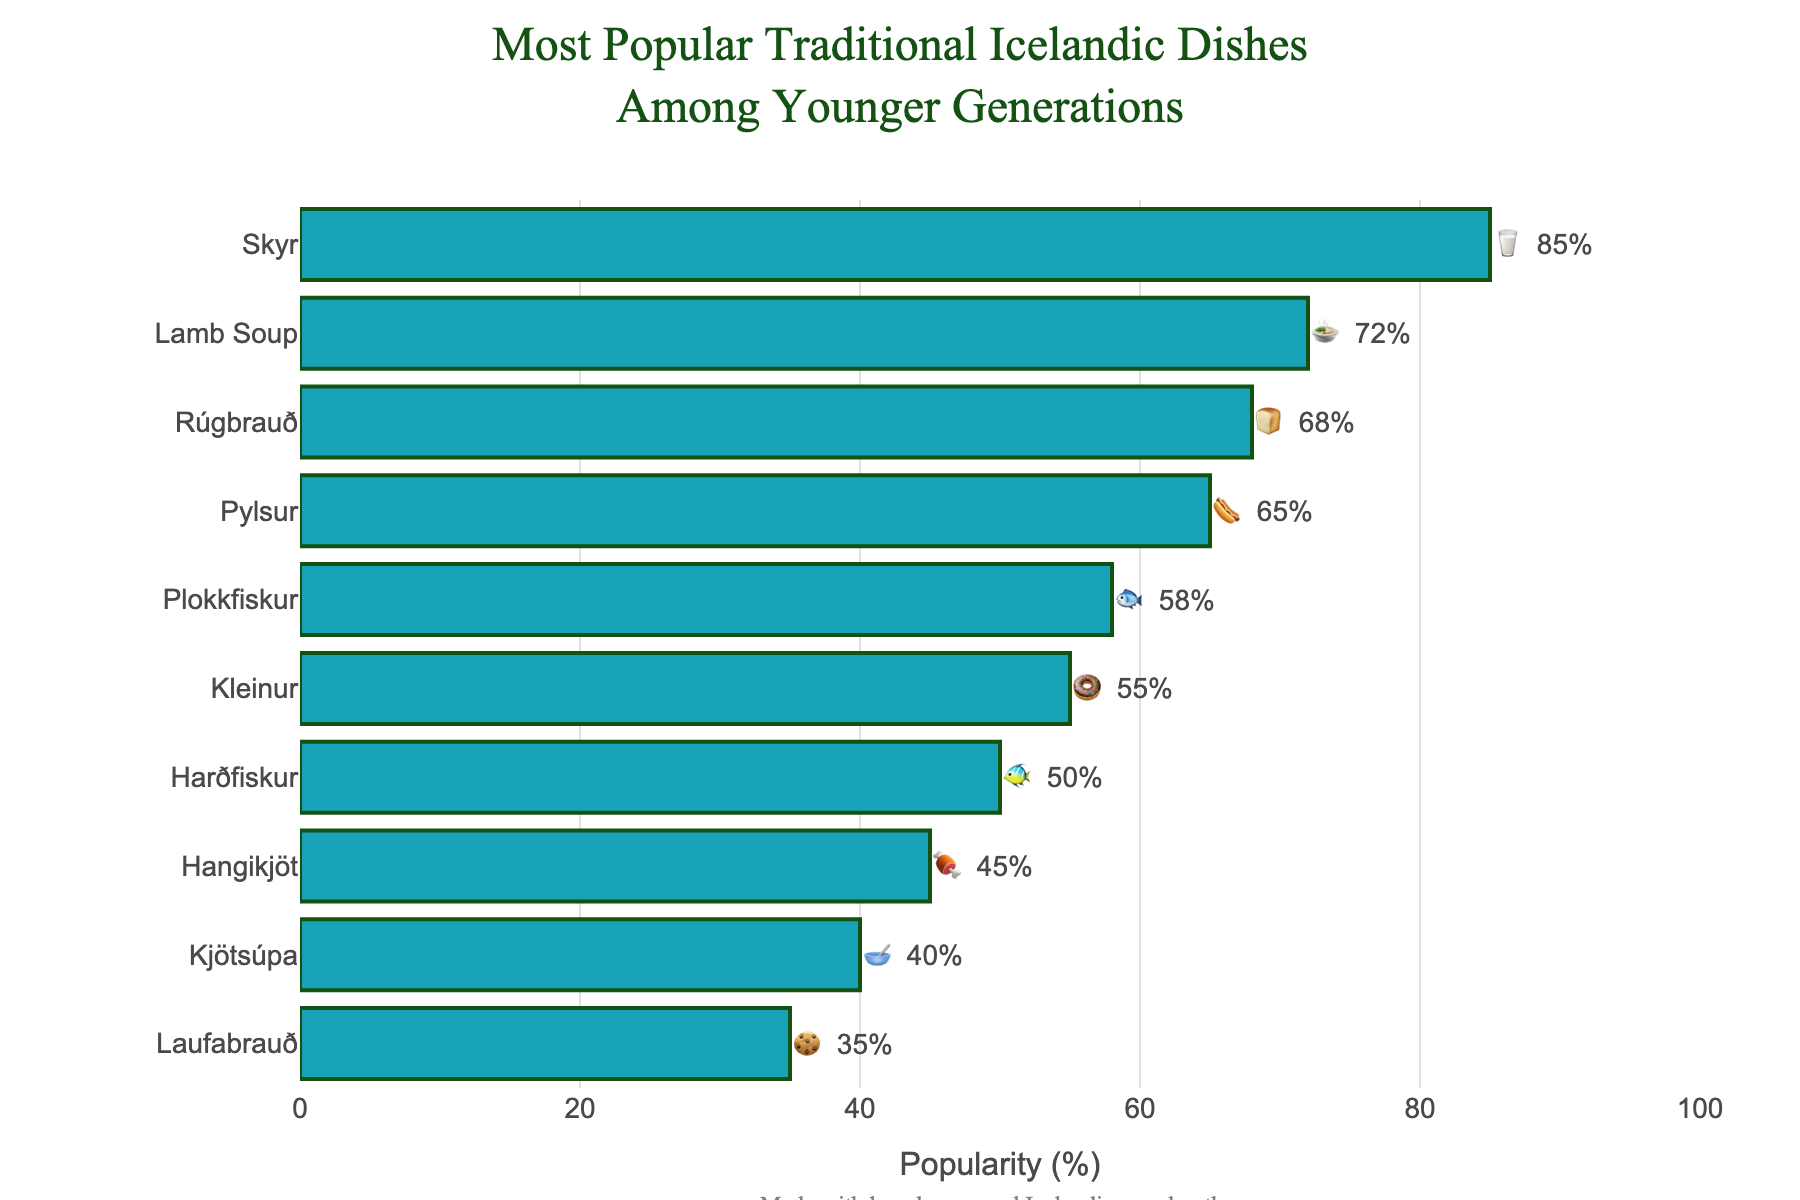Which dish is the most popular among younger generations? The most popular dish is the one with the highest percentage of popularity. From the figure, "Skyr" has the highest popularity at 85%.
Answer: Skyr What is the least popular dish among younger generations? The least popular dish is the one with the lowest percentage of popularity. From the figure, "Laufabrauð" has the lowest popularity at 35%.
Answer: Laufabrauð How much more popular is Skyr than Hangikjöt? To find the difference in popularity, subtract the lower percentage from the higher percentage: 85% (Skyr) - 45% (Hangikjöt) = 40%.
Answer: 40% Which dish is more popular, Pylsur or Rúgbrauð? Compare the popularity percentages for each dish. "Pylsur" has a popularity of 65%, and "Rúgbrauð" has 68%. Therefore, "Rúgbrauð" is more popular.
Answer: Rúgbrauð How many dishes have a popularity of 50% or greater? Count the number of dishes with a popularity percentage of 50% or higher. They are: Skyr, Lamb Soup, Rúgbrauð, Pylsur, Plokkfiskur, and Kleinur. Thus, there are 6 dishes.
Answer: 6 What is the combined popularity of Lamb Soup and Plokkfiskur? Add the popularity percentages of Lamb Soup (72%) and Plokkfiskur (58%): 72% + 58% = 130%.
Answer: 130% What is the average popularity of all the dishes listed? Add the popularity percentages of all the dishes and then divide by the number of dishes: (85 + 72 + 68 + 65 + 58 + 55 + 50 + 45 + 40 + 35) / 10 = 57.3%.
Answer: 57.3% Which dish is represented by the 🐠 emoji, and what is its popularity? The 🐠 emoji represents Harðfiskur, and its popularity is shown as 50% in the chart.
Answer: Harðfiskur, 50% Between Rúgbrauð and Plokkfiskur, which one is less popular and by how much? Compare their popularity: Rúgbrauð (68%), Plokkfiskur (58%). To find the difference, subtract the lower from the higher: 68% - 58% = 10%. So, Plokkfiskur is less popular by 10%.
Answer: Plokkfiskur, 10% 